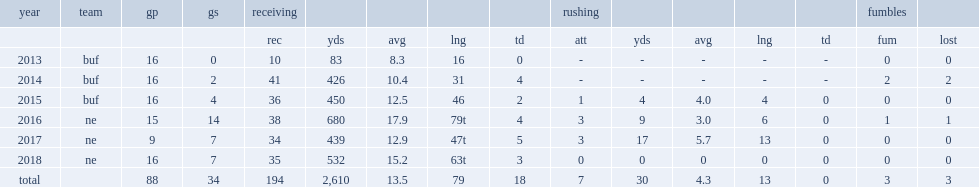In 2018, how many receiving yards did chris hogan make? 532.0. 